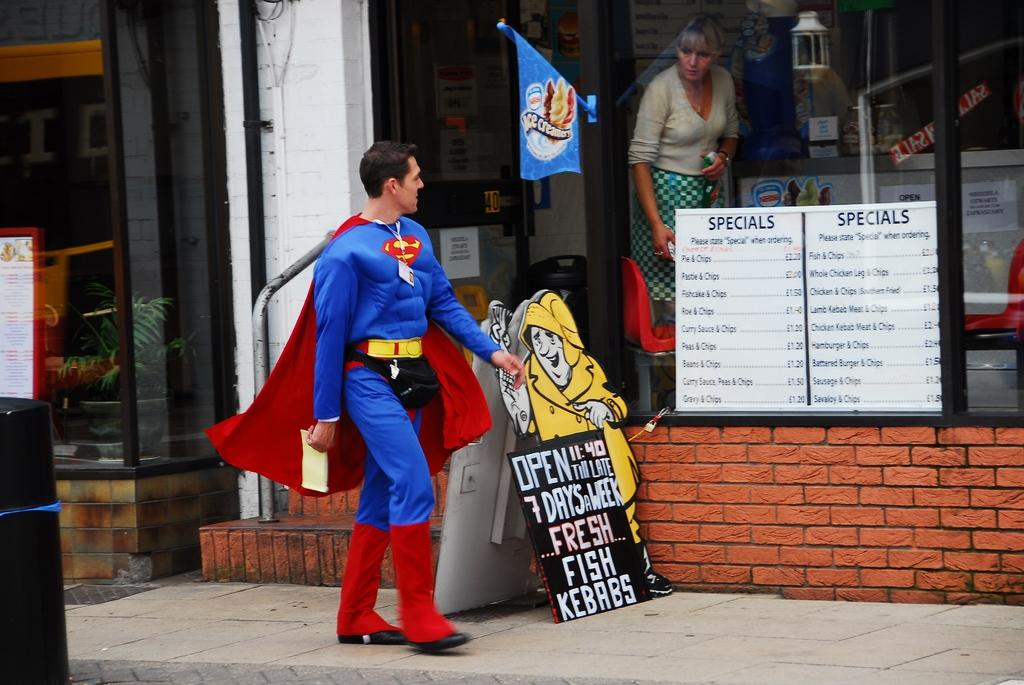Who is the main subject in the image? There is a man in the image, and he is wearing a costume of Superman. Who else is present in the image? There is also a woman in the image. What is the woman doing in the image? The woman is looking at the man. What else can be seen in the image? There is a list of food menu in the image. What color is the story in the image? There is no story present in the image. The image contains a man in a Superman costume, a woman, and a list of food menu. 